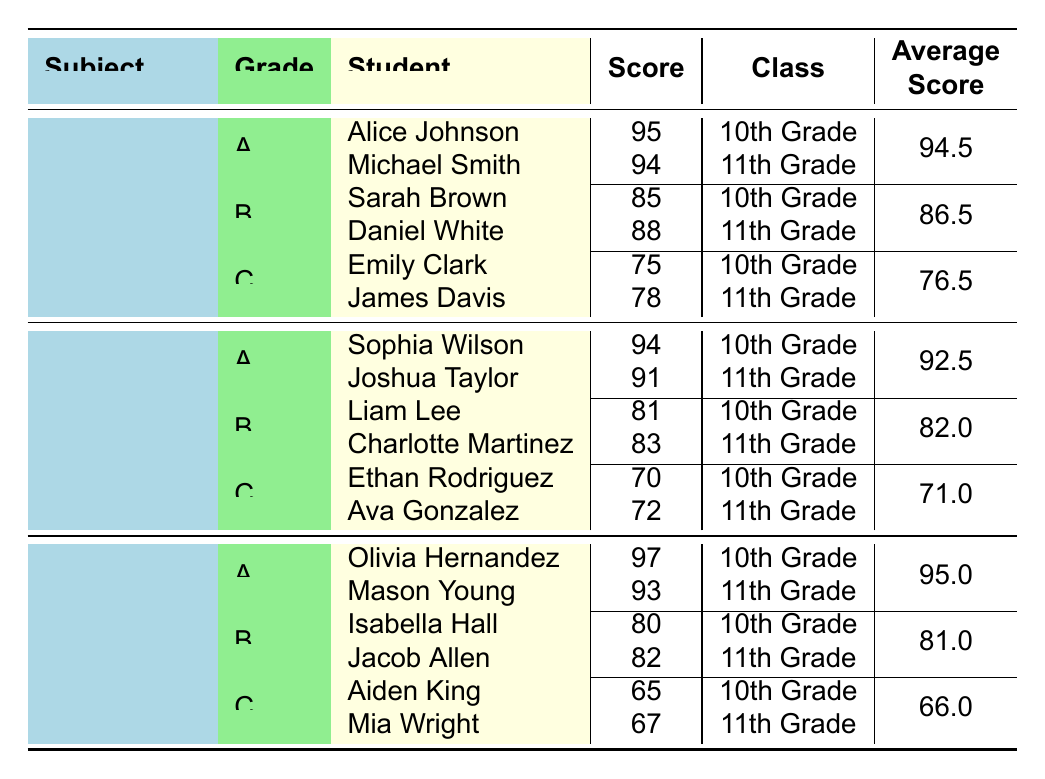What is the highest score in Mathematics among 10th Grade students? In the Mathematics section, for 10th Grade, Alice Johnson scored 95 and Sarah Brown scored 85. The highest score is therefore 95.
Answer: 95 Which student received a grade of B in Science? In the Science section, the students who received a grade of B are Liam Lee and Charlotte Martinez.
Answer: Liam Lee and Charlotte Martinez What is the average score of students who received a grade of C in English? In the English section, Aiden King scored 65 and Mia Wright scored 67. To find the average, add the two scores: 65 + 67 = 132, and divide by 2, which gives 132 / 2 = 66.
Answer: 66 Did any student receive a score of 90 or above in the Science subject? Checking the Science scores, Sophia Wilson scored 94 and Joshua Taylor scored 91, both of which are 90 or above. Therefore, the answer is yes.
Answer: Yes Who has the highest average score among the subjects? The average scores for each subject are as follows: Mathematics - 86.5, Science - 82.0, English - 95.0. The highest average score is 95.0 for English.
Answer: English What is the total number of students who received a grade of A in Mathematics and English combined? For Mathematics, 2 students received grade A (Alice Johnson and Michael Smith). For English, 2 students received grade A (Olivia Hernandez and Mason Young). The total is 2 + 2 = 4 students.
Answer: 4 Which student scored the lowest in Mathematics? In the Mathematics section, the lowest score is 75, achieved by Emily Clark in 10th Grade.
Answer: Emily Clark Is the average score for grade B in Mathematics higher than that in Science? The average for grade B in Mathematics is 86.5, while for Science it is 82.0. Since 86.5 is greater than 82.0, the answer is yes.
Answer: Yes What proportion of students scored above 90 in English? In English, two students scored above 90 (Olivia Hernandez - 97 and Mason Young - 93), out of a total of 6 students across all grades and subjects. The proportion is 2 out of 6, which does not simplify further in terms of a fraction.
Answer: 1/3 